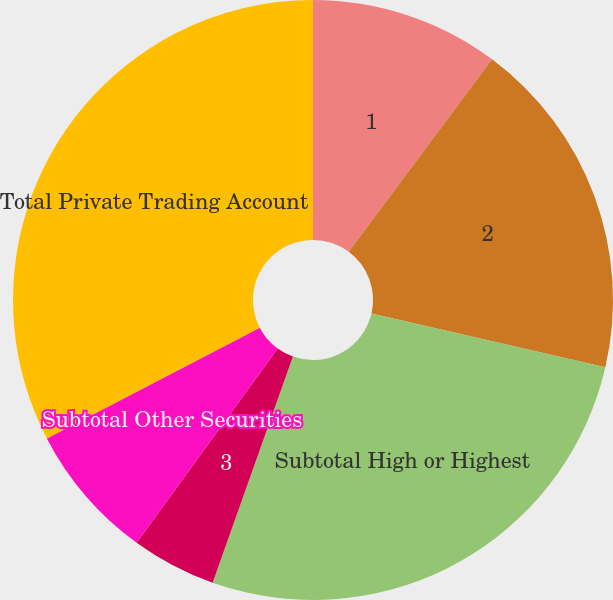<chart> <loc_0><loc_0><loc_500><loc_500><pie_chart><fcel>1<fcel>2<fcel>Subtotal High or Highest<fcel>3<fcel>Subtotal Other Securities<fcel>Total Private Trading Account<nl><fcel>10.18%<fcel>18.42%<fcel>26.83%<fcel>4.57%<fcel>7.37%<fcel>32.63%<nl></chart> 